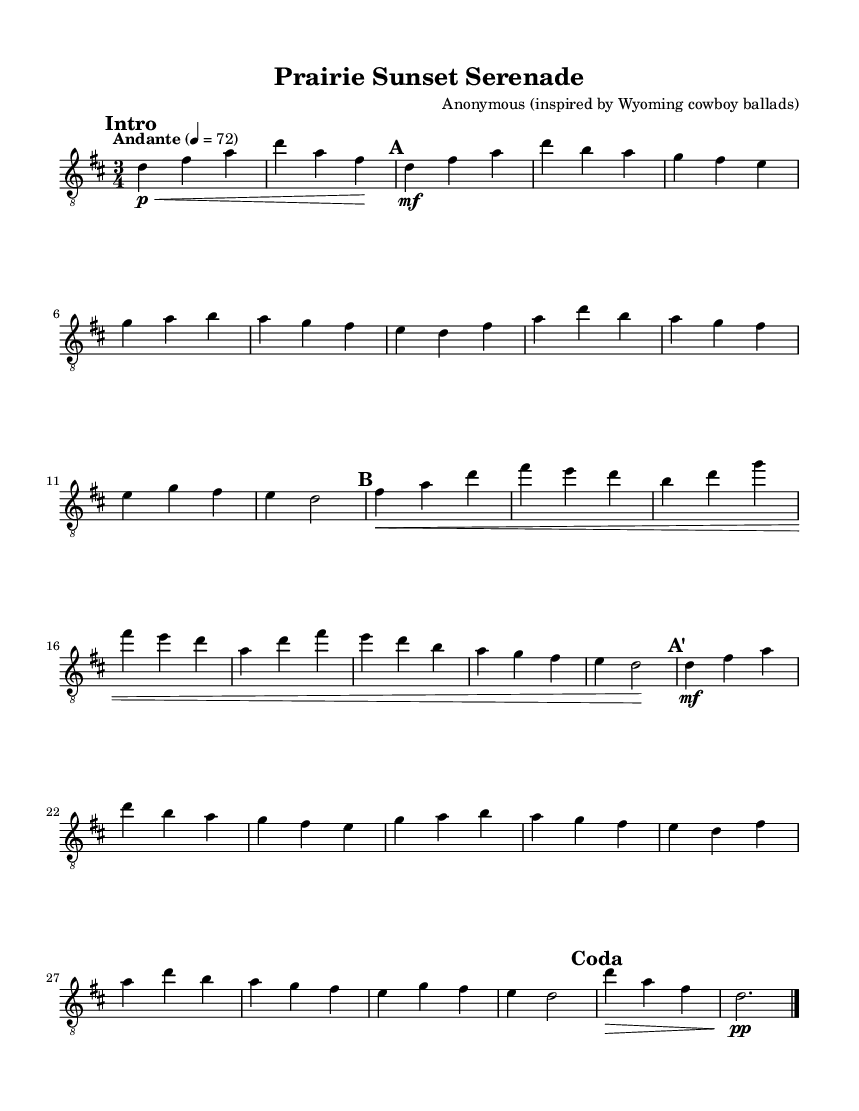What is the key signature of this music? The key signature is D major, which has two sharps (F# and C#). This can be determined by looking at the key signature indicator on the staff at the beginning of the piece.
Answer: D major What is the time signature of this music? The time signature is 3/4, indicated at the beginning of the score. This means there are three beats in each measure, with each beat being a quarter note.
Answer: 3/4 What is the tempo marking in this composition? The tempo marking is "Andante," which indicates a moderate speed. This can be seen written above the staff at the beginning of the score, along with a metronome marking of quarter note equals 72.
Answer: Andante How many sections are in the piece? There are three main sections (A, B, A') plus an intro and a coda. This is noted in the score with marked sections "Intro," "A," "B," "A'," and "Coda."
Answer: Five What does the "mf" marking indicate in the music? The "mf" marking stands for "mezzo-forte," which means moderately loud. This marking can be found within the music, instructing the player to perform those specific measures at a medium loud volume.
Answer: Mezzo-forte What is the final dynamic marking in the composition? The final dynamic marking is "pp," meaning pianissimo, or very soft. This marking appears in the coda section and indicates how softly the music should be played at the end.
Answer: Pianissimo What kind of instrument is indicated in the score? The instrument indicated in the score is "acoustic guitar (nylon)," which is specified in the staff settings. This tells performers which type of instrument to use when interpreting the music.
Answer: Acoustic guitar (nylon) 